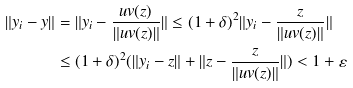Convert formula to latex. <formula><loc_0><loc_0><loc_500><loc_500>\| y _ { i } - y \| & = \| y _ { i } - \frac { u v ( z ) } { \| u v ( z ) \| } \| \leq ( 1 + \delta ) ^ { 2 } \| y _ { i } - \frac { z } { \| u v ( z ) \| } \| \\ & \leq ( 1 + \delta ) ^ { 2 } ( \| y _ { i } - z \| + \| z - \frac { z } { \| u v ( z ) \| } \| ) < 1 + \varepsilon</formula> 